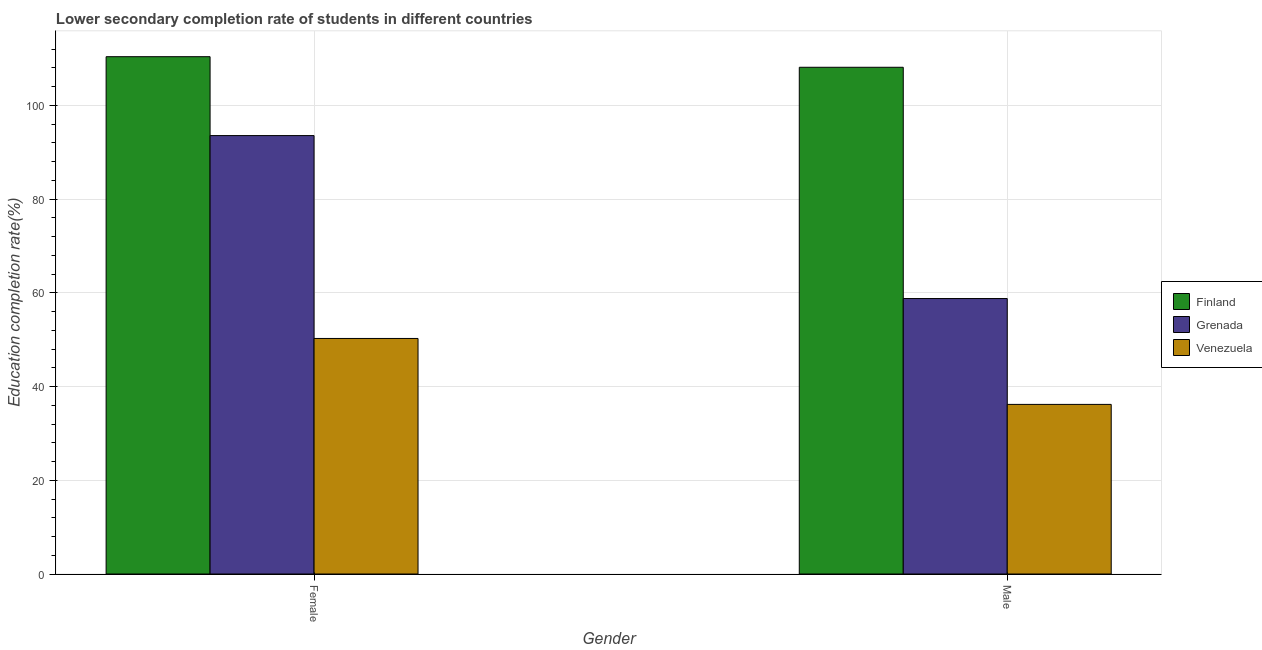How many groups of bars are there?
Keep it short and to the point. 2. Are the number of bars per tick equal to the number of legend labels?
Your response must be concise. Yes. Are the number of bars on each tick of the X-axis equal?
Provide a succinct answer. Yes. How many bars are there on the 2nd tick from the left?
Provide a succinct answer. 3. What is the education completion rate of female students in Grenada?
Offer a terse response. 93.54. Across all countries, what is the maximum education completion rate of female students?
Keep it short and to the point. 110.38. Across all countries, what is the minimum education completion rate of male students?
Make the answer very short. 36.19. In which country was the education completion rate of male students maximum?
Provide a succinct answer. Finland. In which country was the education completion rate of female students minimum?
Keep it short and to the point. Venezuela. What is the total education completion rate of male students in the graph?
Your answer should be very brief. 203.08. What is the difference between the education completion rate of male students in Grenada and that in Finland?
Provide a short and direct response. -49.34. What is the difference between the education completion rate of male students in Finland and the education completion rate of female students in Grenada?
Ensure brevity in your answer.  14.58. What is the average education completion rate of male students per country?
Your response must be concise. 67.69. What is the difference between the education completion rate of female students and education completion rate of male students in Finland?
Make the answer very short. 2.26. What is the ratio of the education completion rate of male students in Venezuela to that in Finland?
Offer a terse response. 0.33. In how many countries, is the education completion rate of male students greater than the average education completion rate of male students taken over all countries?
Your response must be concise. 1. What does the 2nd bar from the left in Female represents?
Your answer should be compact. Grenada. What does the 3rd bar from the right in Female represents?
Keep it short and to the point. Finland. How many bars are there?
Your answer should be compact. 6. How many countries are there in the graph?
Make the answer very short. 3. What is the difference between two consecutive major ticks on the Y-axis?
Keep it short and to the point. 20. Does the graph contain any zero values?
Give a very brief answer. No. How many legend labels are there?
Keep it short and to the point. 3. How are the legend labels stacked?
Offer a very short reply. Vertical. What is the title of the graph?
Offer a terse response. Lower secondary completion rate of students in different countries. What is the label or title of the X-axis?
Provide a short and direct response. Gender. What is the label or title of the Y-axis?
Provide a succinct answer. Education completion rate(%). What is the Education completion rate(%) in Finland in Female?
Ensure brevity in your answer.  110.38. What is the Education completion rate(%) of Grenada in Female?
Keep it short and to the point. 93.54. What is the Education completion rate(%) in Venezuela in Female?
Ensure brevity in your answer.  50.25. What is the Education completion rate(%) in Finland in Male?
Give a very brief answer. 108.12. What is the Education completion rate(%) of Grenada in Male?
Give a very brief answer. 58.77. What is the Education completion rate(%) in Venezuela in Male?
Provide a short and direct response. 36.19. Across all Gender, what is the maximum Education completion rate(%) of Finland?
Provide a succinct answer. 110.38. Across all Gender, what is the maximum Education completion rate(%) in Grenada?
Offer a terse response. 93.54. Across all Gender, what is the maximum Education completion rate(%) in Venezuela?
Your response must be concise. 50.25. Across all Gender, what is the minimum Education completion rate(%) in Finland?
Ensure brevity in your answer.  108.12. Across all Gender, what is the minimum Education completion rate(%) of Grenada?
Ensure brevity in your answer.  58.77. Across all Gender, what is the minimum Education completion rate(%) of Venezuela?
Ensure brevity in your answer.  36.19. What is the total Education completion rate(%) in Finland in the graph?
Give a very brief answer. 218.49. What is the total Education completion rate(%) of Grenada in the graph?
Your answer should be very brief. 152.32. What is the total Education completion rate(%) in Venezuela in the graph?
Offer a terse response. 86.44. What is the difference between the Education completion rate(%) in Finland in Female and that in Male?
Your response must be concise. 2.26. What is the difference between the Education completion rate(%) in Grenada in Female and that in Male?
Provide a short and direct response. 34.77. What is the difference between the Education completion rate(%) in Venezuela in Female and that in Male?
Provide a succinct answer. 14.07. What is the difference between the Education completion rate(%) of Finland in Female and the Education completion rate(%) of Grenada in Male?
Give a very brief answer. 51.6. What is the difference between the Education completion rate(%) of Finland in Female and the Education completion rate(%) of Venezuela in Male?
Your response must be concise. 74.19. What is the difference between the Education completion rate(%) of Grenada in Female and the Education completion rate(%) of Venezuela in Male?
Your response must be concise. 57.35. What is the average Education completion rate(%) in Finland per Gender?
Make the answer very short. 109.25. What is the average Education completion rate(%) of Grenada per Gender?
Keep it short and to the point. 76.16. What is the average Education completion rate(%) in Venezuela per Gender?
Your answer should be very brief. 43.22. What is the difference between the Education completion rate(%) of Finland and Education completion rate(%) of Grenada in Female?
Offer a terse response. 16.83. What is the difference between the Education completion rate(%) in Finland and Education completion rate(%) in Venezuela in Female?
Provide a short and direct response. 60.12. What is the difference between the Education completion rate(%) of Grenada and Education completion rate(%) of Venezuela in Female?
Keep it short and to the point. 43.29. What is the difference between the Education completion rate(%) of Finland and Education completion rate(%) of Grenada in Male?
Your answer should be compact. 49.34. What is the difference between the Education completion rate(%) in Finland and Education completion rate(%) in Venezuela in Male?
Ensure brevity in your answer.  71.93. What is the difference between the Education completion rate(%) in Grenada and Education completion rate(%) in Venezuela in Male?
Offer a terse response. 22.59. What is the ratio of the Education completion rate(%) of Finland in Female to that in Male?
Provide a succinct answer. 1.02. What is the ratio of the Education completion rate(%) in Grenada in Female to that in Male?
Make the answer very short. 1.59. What is the ratio of the Education completion rate(%) in Venezuela in Female to that in Male?
Offer a very short reply. 1.39. What is the difference between the highest and the second highest Education completion rate(%) of Finland?
Make the answer very short. 2.26. What is the difference between the highest and the second highest Education completion rate(%) in Grenada?
Provide a succinct answer. 34.77. What is the difference between the highest and the second highest Education completion rate(%) in Venezuela?
Your answer should be compact. 14.07. What is the difference between the highest and the lowest Education completion rate(%) in Finland?
Give a very brief answer. 2.26. What is the difference between the highest and the lowest Education completion rate(%) in Grenada?
Offer a terse response. 34.77. What is the difference between the highest and the lowest Education completion rate(%) in Venezuela?
Your answer should be compact. 14.07. 